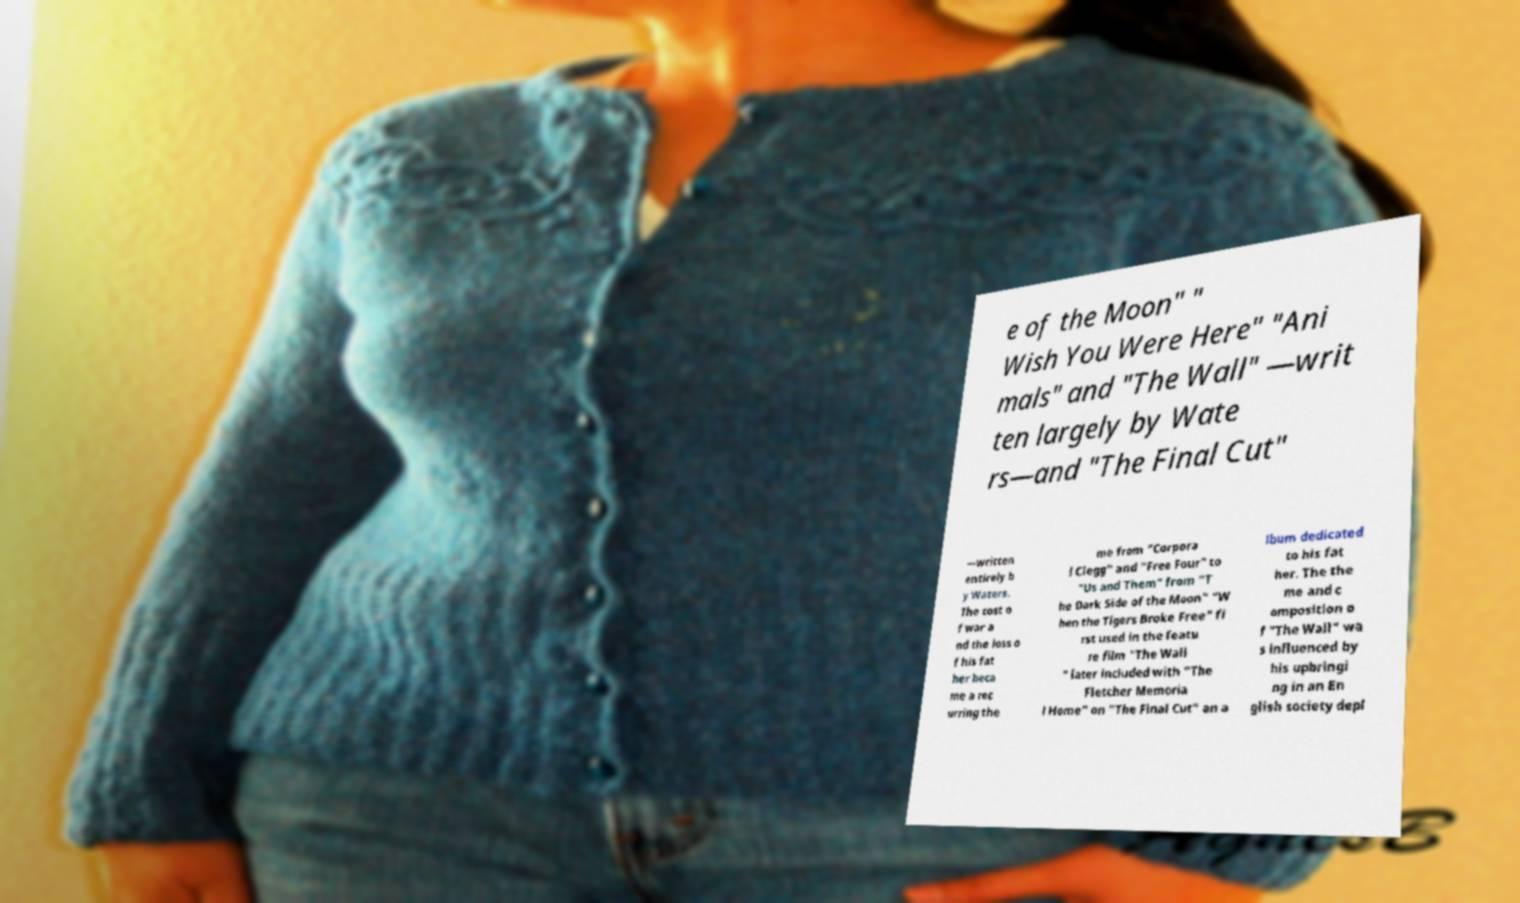Please read and relay the text visible in this image. What does it say? e of the Moon" " Wish You Were Here" "Ani mals" and "The Wall" —writ ten largely by Wate rs—and "The Final Cut" —written entirely b y Waters. The cost o f war a nd the loss o f his fat her beca me a rec urring the me from "Corpora l Clegg" and "Free Four" to "Us and Them" from "T he Dark Side of the Moon" "W hen the Tigers Broke Free" fi rst used in the featu re film "The Wall " later included with "The Fletcher Memoria l Home" on "The Final Cut" an a lbum dedicated to his fat her. The the me and c omposition o f "The Wall" wa s influenced by his upbringi ng in an En glish society depl 